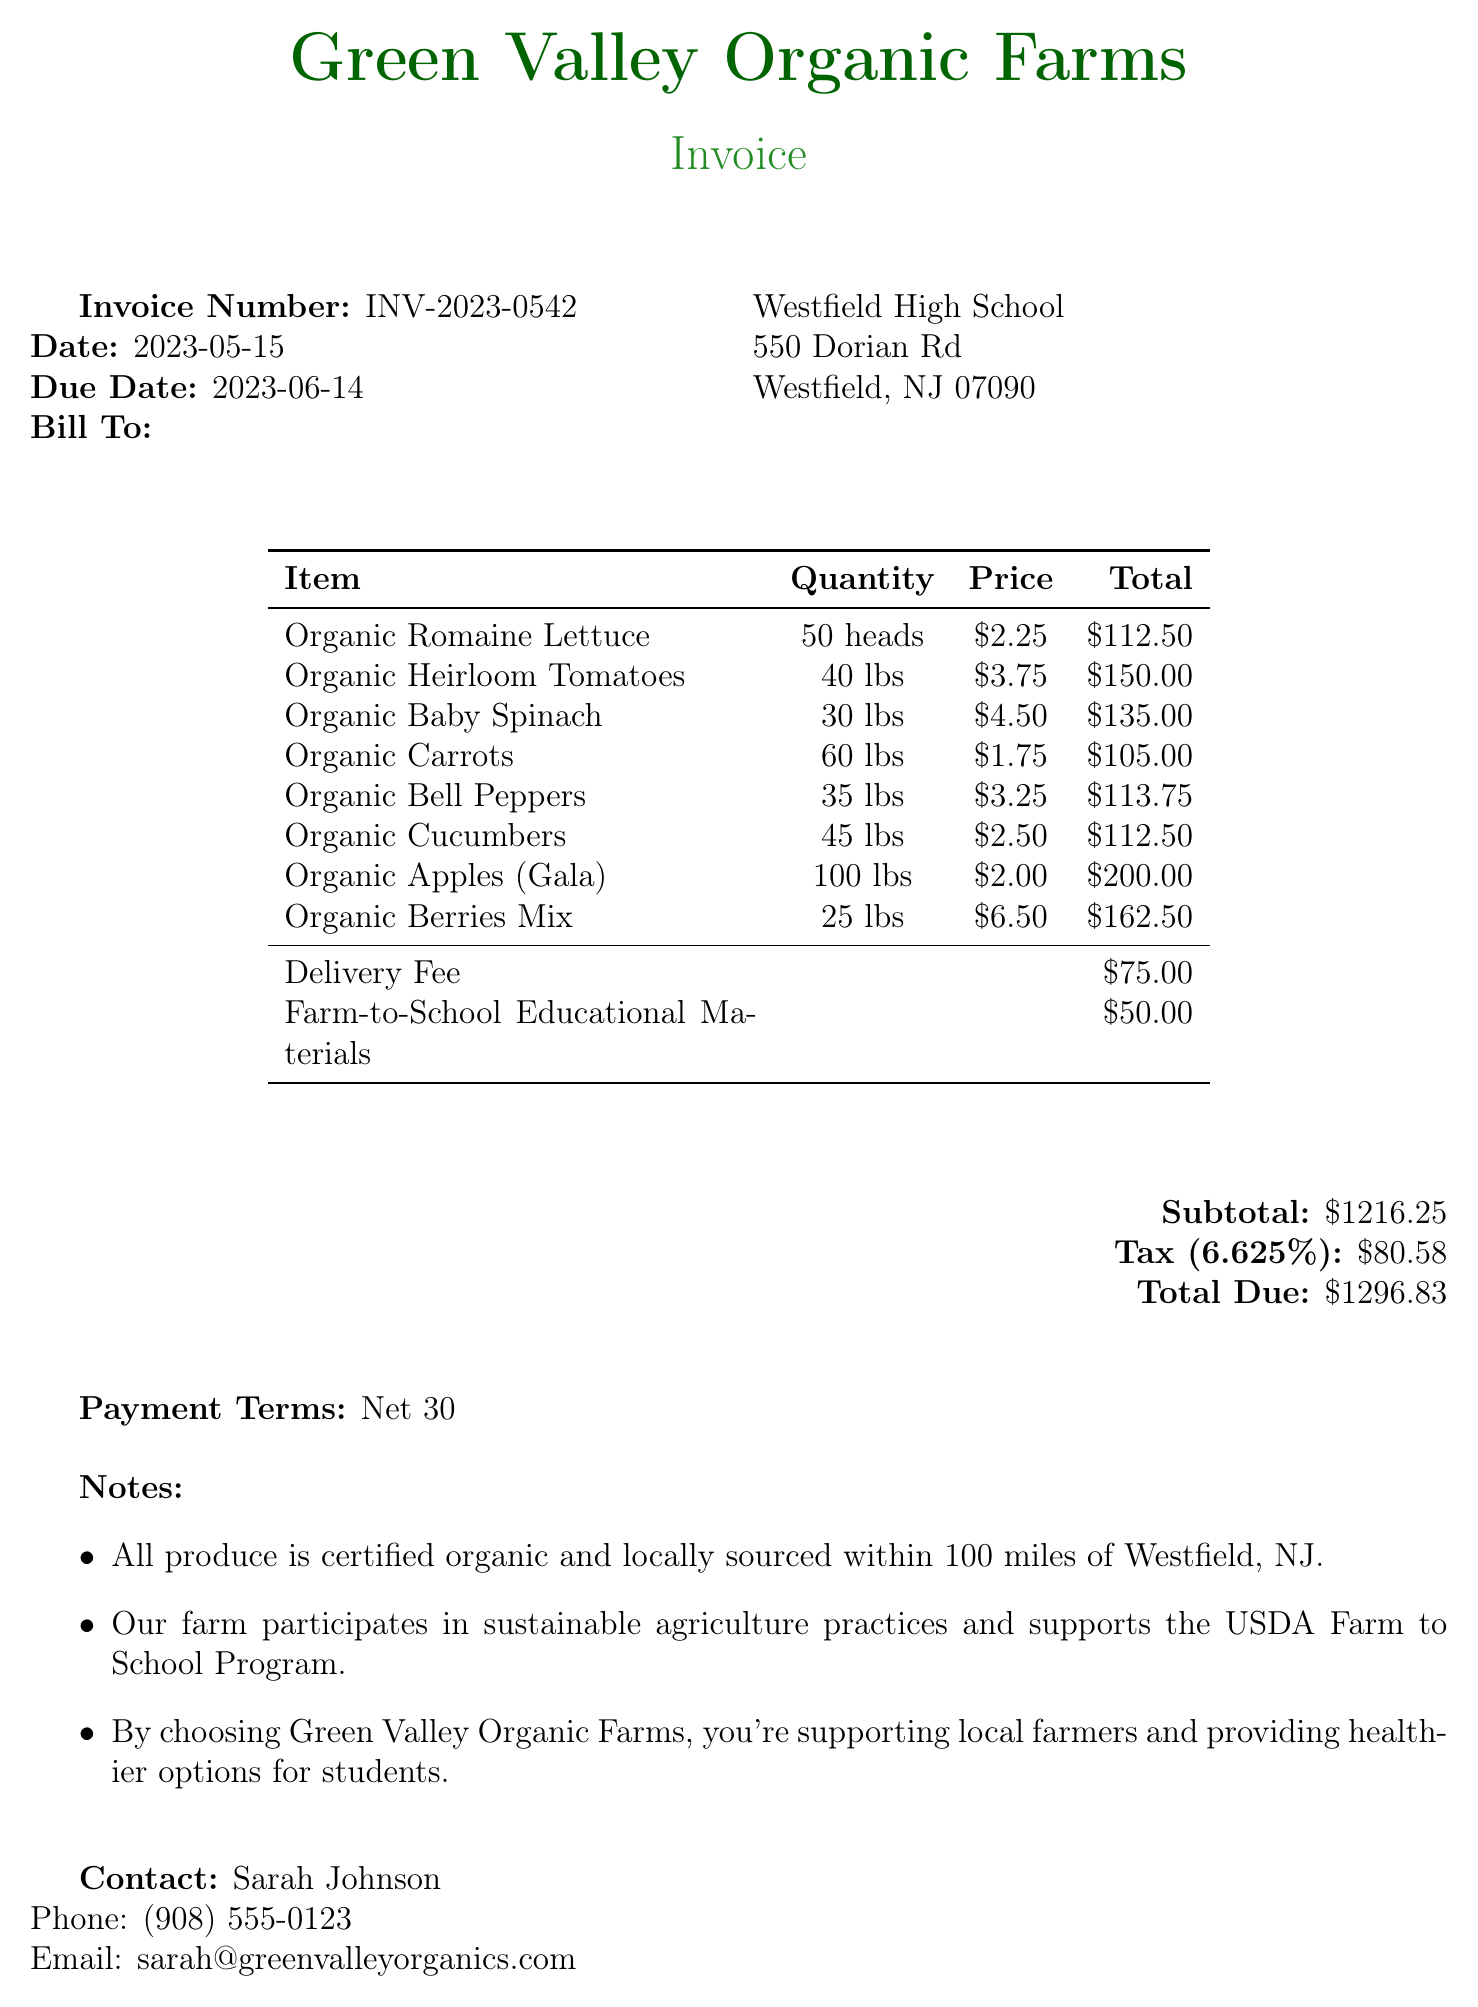What is the supplier's name? The supplier's name is listed in the document as the source of the invoice.
Answer: Green Valley Organic Farms What is the invoice number? The invoice number is clearly stated in the document for reference.
Answer: INV-2023-0542 What is the due date for payment? The due date is specified in the invoice, indicating when payment is required.
Answer: 2023-06-14 How much were the organic apples? The specific price for each item is included in the line items section of the document.
Answer: 200.00 What is the total due amount? The total due is calculated and finalized at the end of the invoice.
Answer: 1296.83 What quantity of organic romaine lettuce was ordered? The quantity appears in the line items detailing each product's order amount.
Answer: 50 What additional cost includes educational materials? The invoice includes a description of certain services or costs that provide context for educational outreach.
Answer: Farm-to-School Educational Materials What percentage tax was applied to the invoice? The tax rate is provided in the totals section, which is relevant to the overall cost.
Answer: 6.625% How many different types of produce are listed in the invoice? The count of the listed items reflects the diversity of produce available on this invoice.
Answer: 8 Who should be contacted for inquiries related to this invoice? The document specifies a contact for any questions about the invoice and supplier.
Answer: Sarah Johnson 